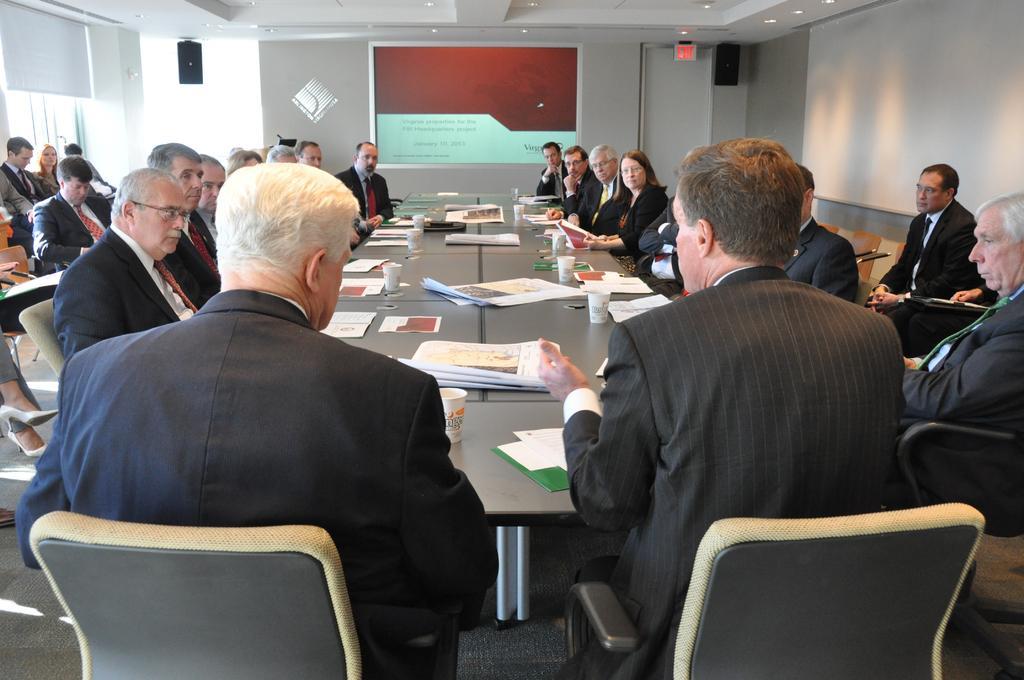Please provide a concise description of this image. There are group of people sitting on the chairs. This is a table with papers,paper cups and few other things. This looks like a screen attached to the wall. These are the speakers hanging to the rooftop. These are the ceiling lights attached to the rooftop. I think this is a door with an exit board. 